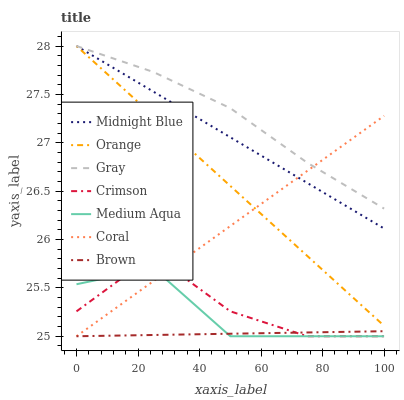Does Brown have the minimum area under the curve?
Answer yes or no. Yes. Does Gray have the maximum area under the curve?
Answer yes or no. Yes. Does Midnight Blue have the minimum area under the curve?
Answer yes or no. No. Does Midnight Blue have the maximum area under the curve?
Answer yes or no. No. Is Brown the smoothest?
Answer yes or no. Yes. Is Crimson the roughest?
Answer yes or no. Yes. Is Midnight Blue the smoothest?
Answer yes or no. No. Is Midnight Blue the roughest?
Answer yes or no. No. Does Brown have the lowest value?
Answer yes or no. Yes. Does Midnight Blue have the lowest value?
Answer yes or no. No. Does Orange have the highest value?
Answer yes or no. Yes. Does Brown have the highest value?
Answer yes or no. No. Is Crimson less than Gray?
Answer yes or no. Yes. Is Orange greater than Brown?
Answer yes or no. Yes. Does Crimson intersect Brown?
Answer yes or no. Yes. Is Crimson less than Brown?
Answer yes or no. No. Is Crimson greater than Brown?
Answer yes or no. No. Does Crimson intersect Gray?
Answer yes or no. No. 